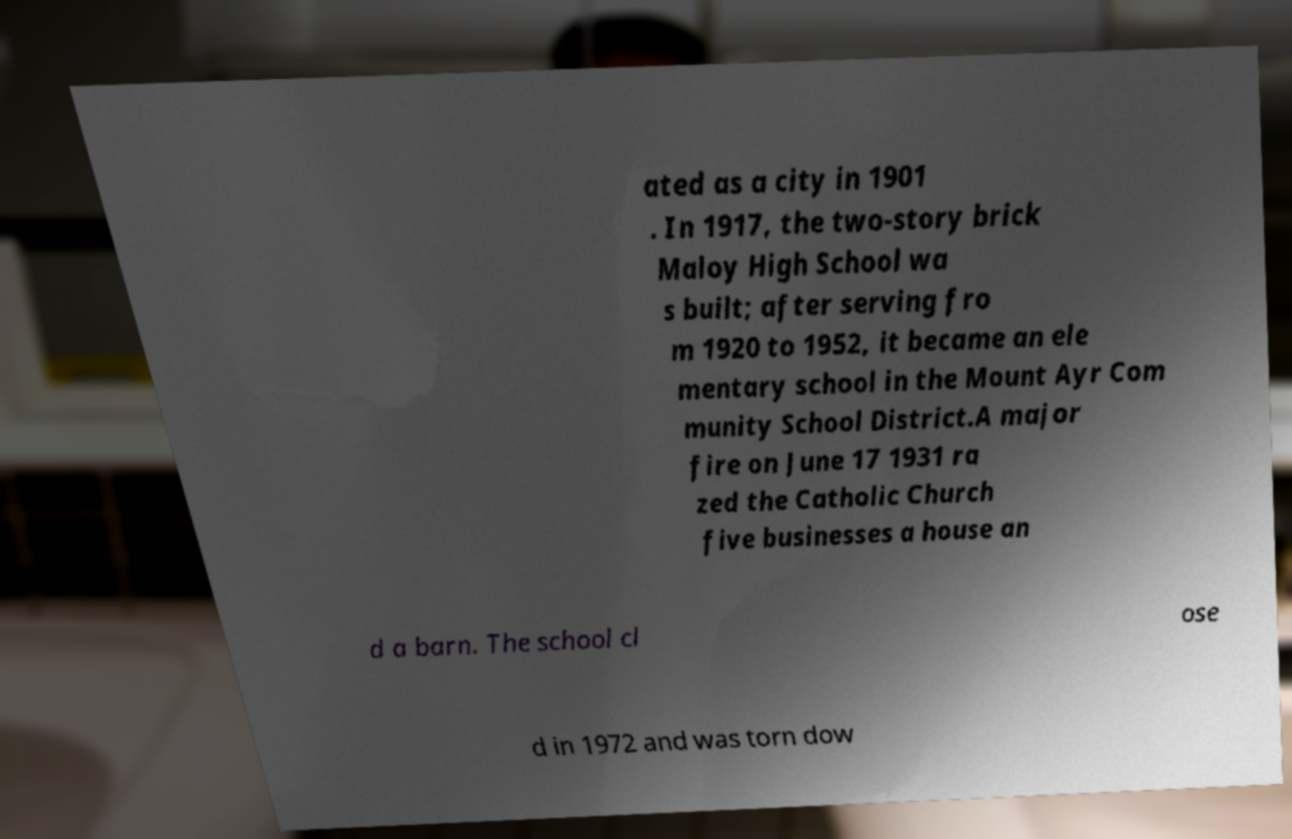I need the written content from this picture converted into text. Can you do that? ated as a city in 1901 . In 1917, the two-story brick Maloy High School wa s built; after serving fro m 1920 to 1952, it became an ele mentary school in the Mount Ayr Com munity School District.A major fire on June 17 1931 ra zed the Catholic Church five businesses a house an d a barn. The school cl ose d in 1972 and was torn dow 